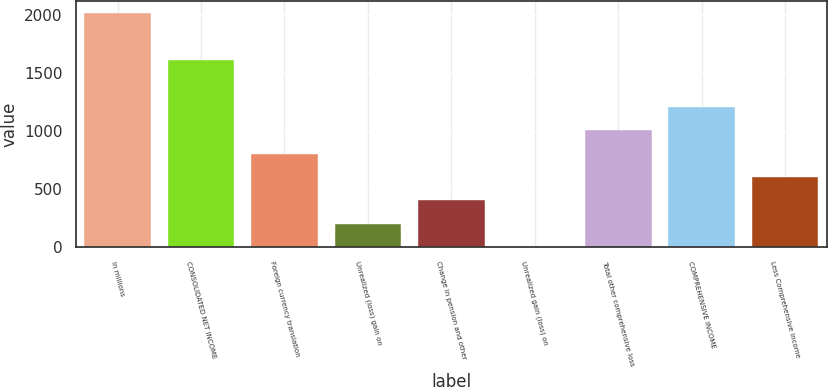Convert chart. <chart><loc_0><loc_0><loc_500><loc_500><bar_chart><fcel>In millions<fcel>CONSOLIDATED NET INCOME<fcel>Foreign currency translation<fcel>Unrealized (loss) gain on<fcel>Change in pension and other<fcel>Unrealized gain (loss) on<fcel>Total other comprehensive loss<fcel>COMPREHENSIVE INCOME<fcel>Less Comprehensive income<nl><fcel>2016<fcel>1613<fcel>807<fcel>202.5<fcel>404<fcel>1<fcel>1008.5<fcel>1210<fcel>605.5<nl></chart> 